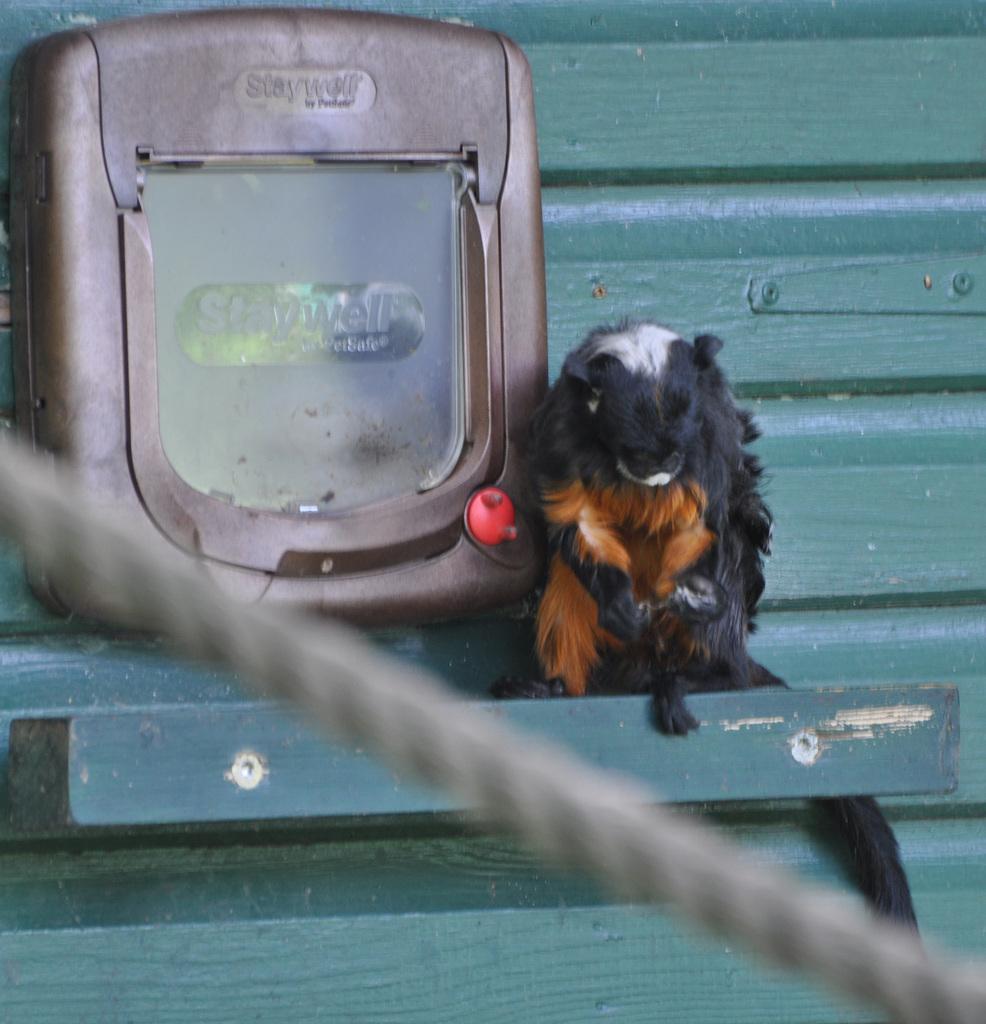How would you summarize this image in a sentence or two? In this image we can see one thread, one object attached to the green color surface and one animal on the surface. 